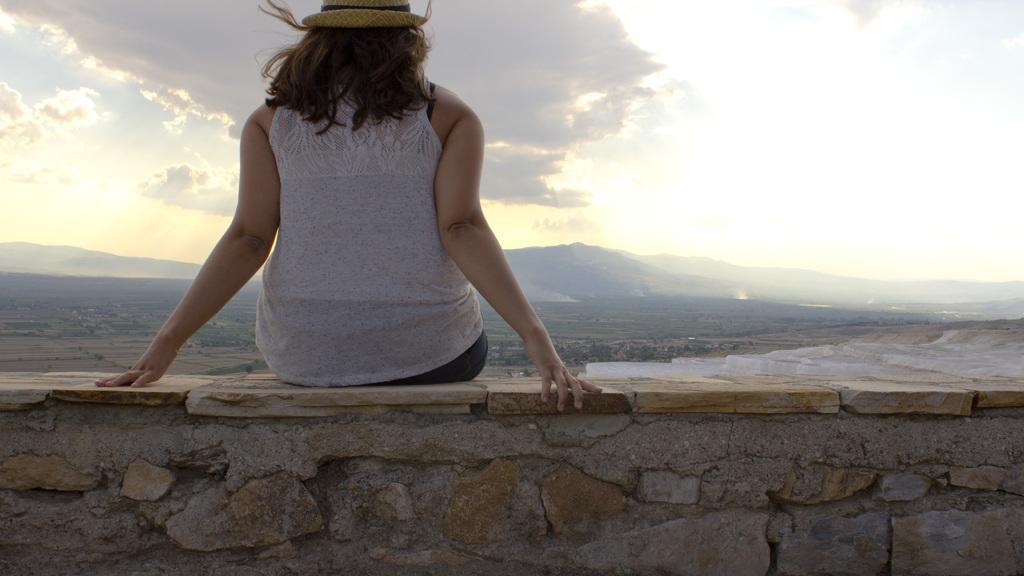Please provide a concise description of this image. In this image, we can see a lady wearing cap and sitting on the wall. At the top, there is sky. 